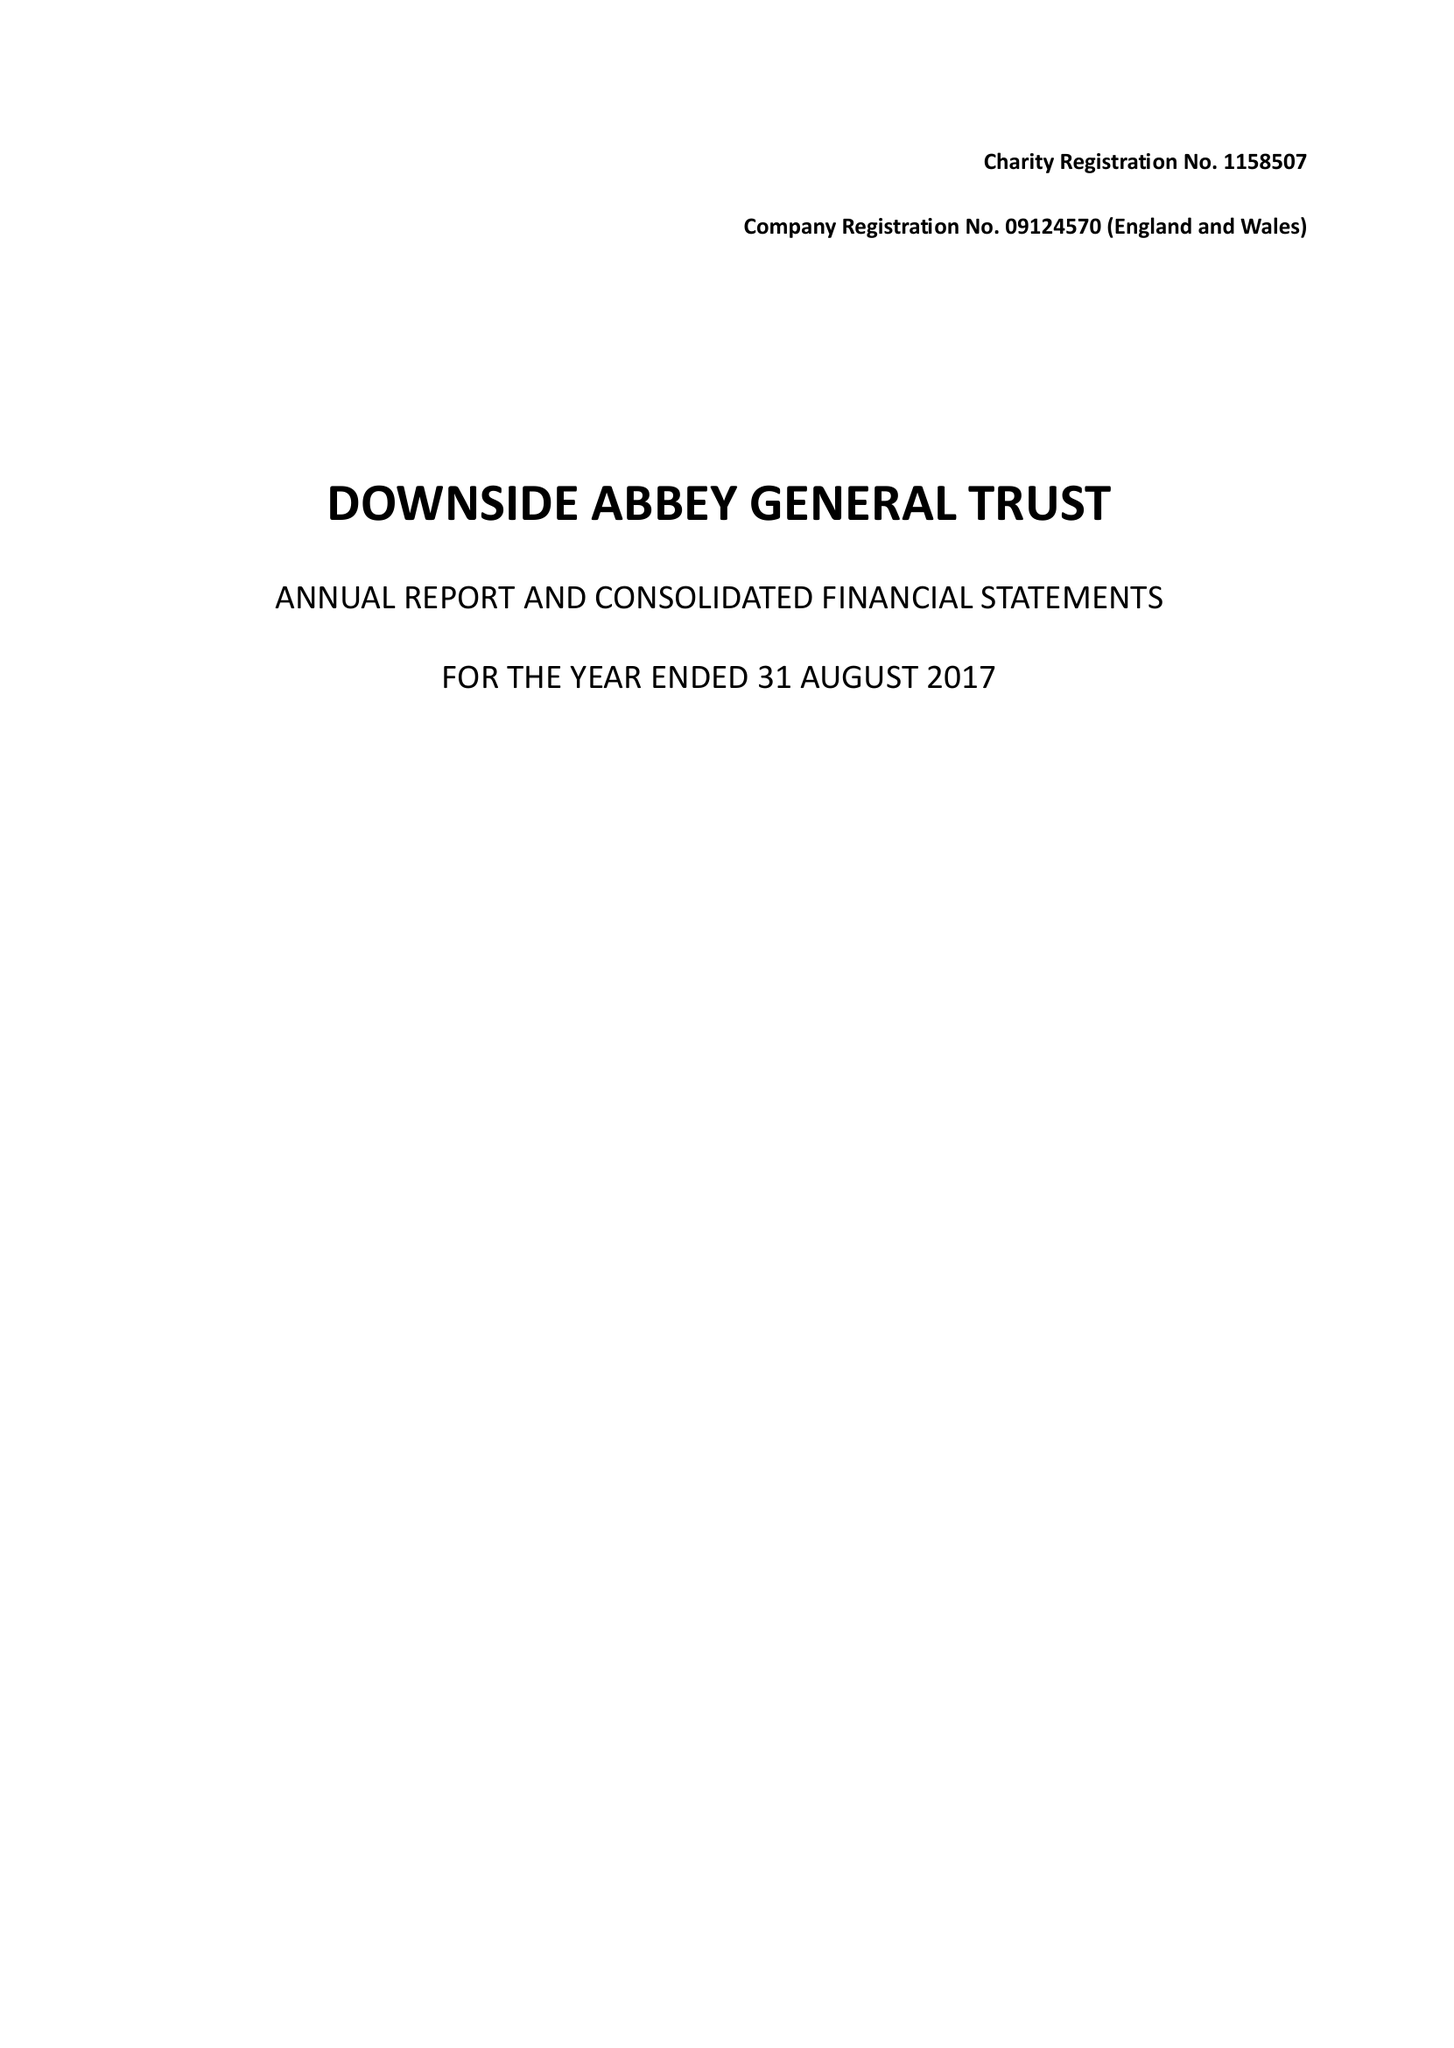What is the value for the address__post_town?
Answer the question using a single word or phrase. RADSTOCK 